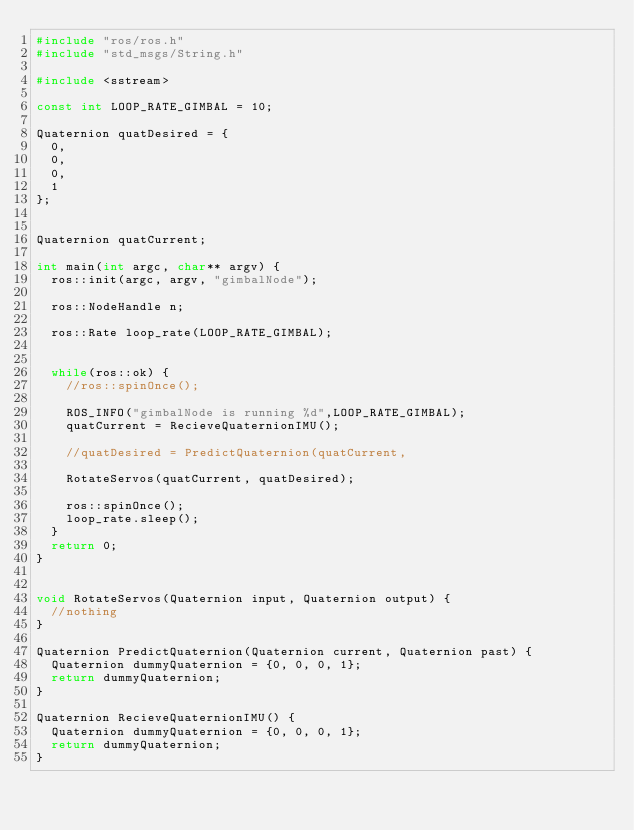Convert code to text. <code><loc_0><loc_0><loc_500><loc_500><_C++_>#include "ros/ros.h"
#include "std_msgs/String.h"

#include <sstream>

const int LOOP_RATE_GIMBAL = 10;

Quaternion quatDesired = {
  0,
  0,
  0,
  1
};


Quaternion quatCurrent;

int main(int argc, char** argv) {
  ros::init(argc, argv, "gimbalNode");
  
  ros::NodeHandle n;

  ros::Rate loop_rate(LOOP_RATE_GIMBAL);
  
  
  while(ros::ok) {
    //ros::spinOnce();
    
    ROS_INFO("gimbalNode is running %d",LOOP_RATE_GIMBAL);
    quatCurrent = RecieveQuaternionIMU();
    
    //quatDesired = PredictQuaternion(quatCurrent, 
    
    RotateServos(quatCurrent, quatDesired);

    ros::spinOnce();
    loop_rate.sleep();
  }
  return 0;
}


void RotateServos(Quaternion input, Quaternion output) {
  //nothing
}

Quaternion PredictQuaternion(Quaternion current, Quaternion past) {
  Quaternion dummyQuaternion = {0, 0, 0, 1};
  return dummyQuaternion;
}

Quaternion RecieveQuaternionIMU() {
  Quaternion dummyQuaternion = {0, 0, 0, 1};
  return dummyQuaternion;
}

</code> 